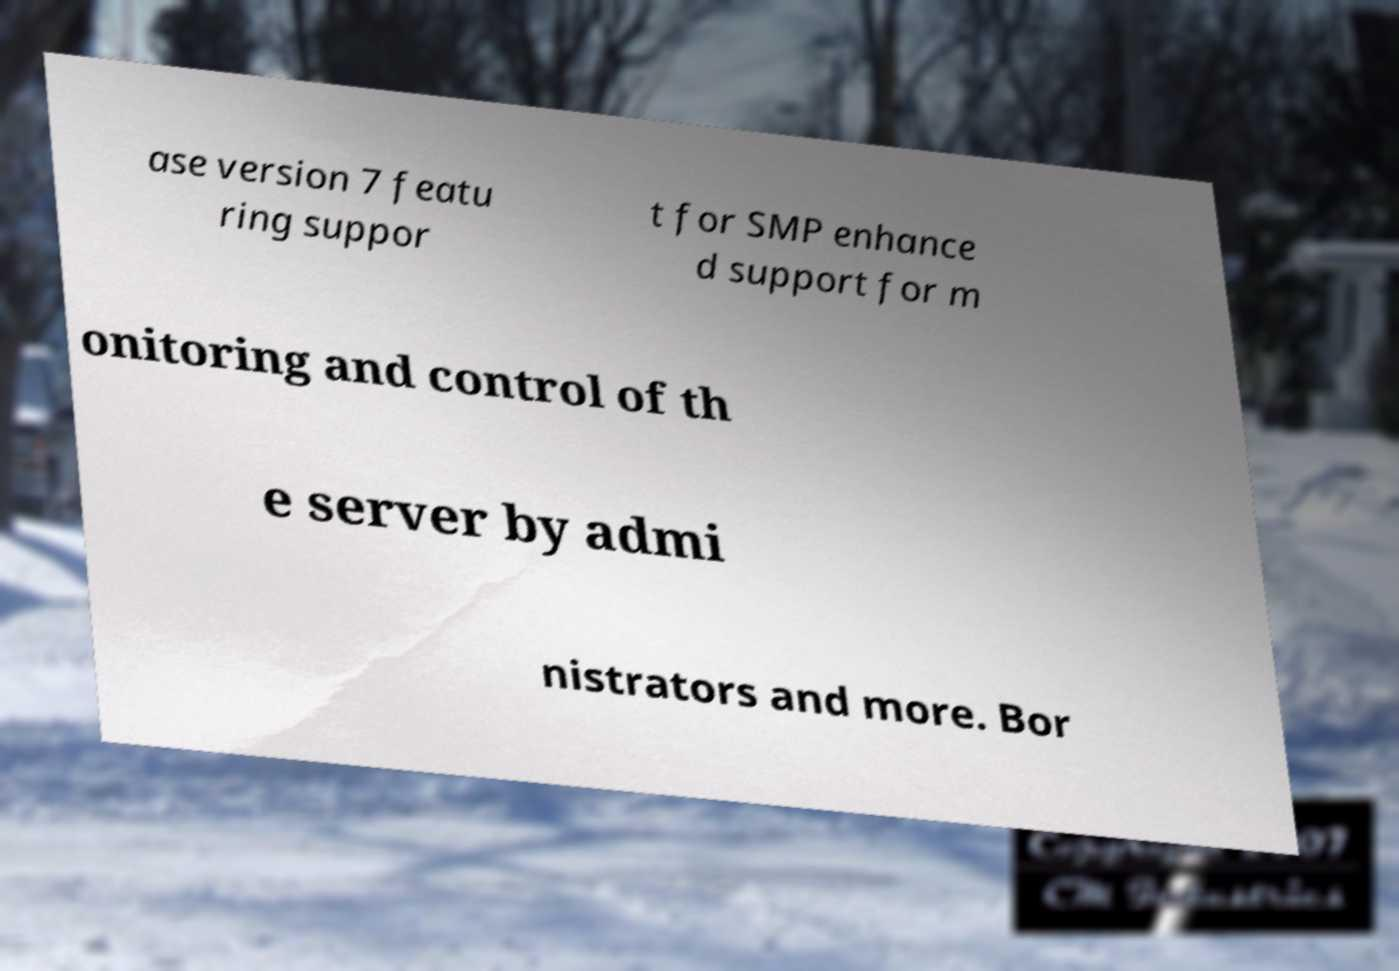What messages or text are displayed in this image? I need them in a readable, typed format. ase version 7 featu ring suppor t for SMP enhance d support for m onitoring and control of th e server by admi nistrators and more. Bor 